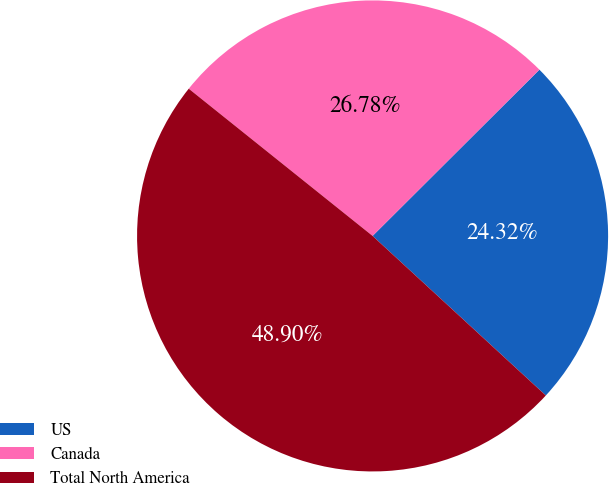Convert chart. <chart><loc_0><loc_0><loc_500><loc_500><pie_chart><fcel>US<fcel>Canada<fcel>Total North America<nl><fcel>24.32%<fcel>26.78%<fcel>48.9%<nl></chart> 